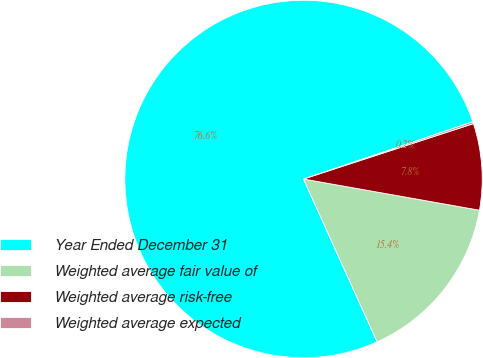Convert chart. <chart><loc_0><loc_0><loc_500><loc_500><pie_chart><fcel>Year Ended December 31<fcel>Weighted average fair value of<fcel>Weighted average risk-free<fcel>Weighted average expected<nl><fcel>76.58%<fcel>15.45%<fcel>7.81%<fcel>0.17%<nl></chart> 